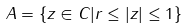<formula> <loc_0><loc_0><loc_500><loc_500>A = \{ z \in C | r \leq | z | \leq 1 \}</formula> 